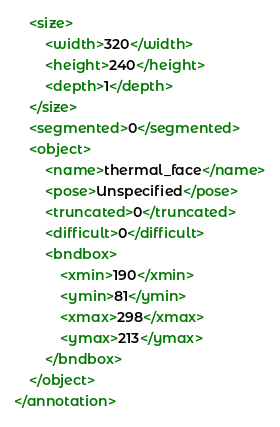Convert code to text. <code><loc_0><loc_0><loc_500><loc_500><_XML_>	<size>
		<width>320</width>
		<height>240</height>
		<depth>1</depth>
	</size>
	<segmented>0</segmented>
	<object>
		<name>thermal_face</name>
		<pose>Unspecified</pose>
		<truncated>0</truncated>
		<difficult>0</difficult>
		<bndbox>
			<xmin>190</xmin>
			<ymin>81</ymin>
			<xmax>298</xmax>
			<ymax>213</ymax>
		</bndbox>
	</object>
</annotation>
</code> 